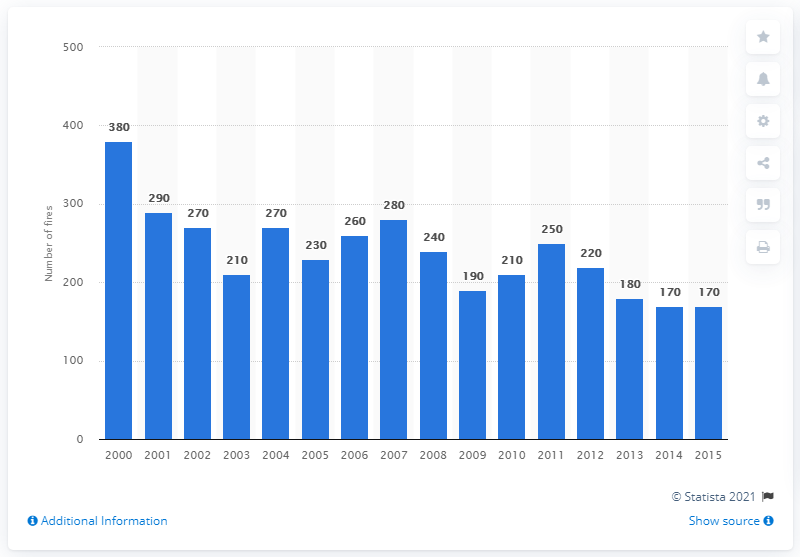Mention a couple of crucial points in this snapshot. In the year 2008, a total of 240 fires in the United States were caused by Christmas trees. 